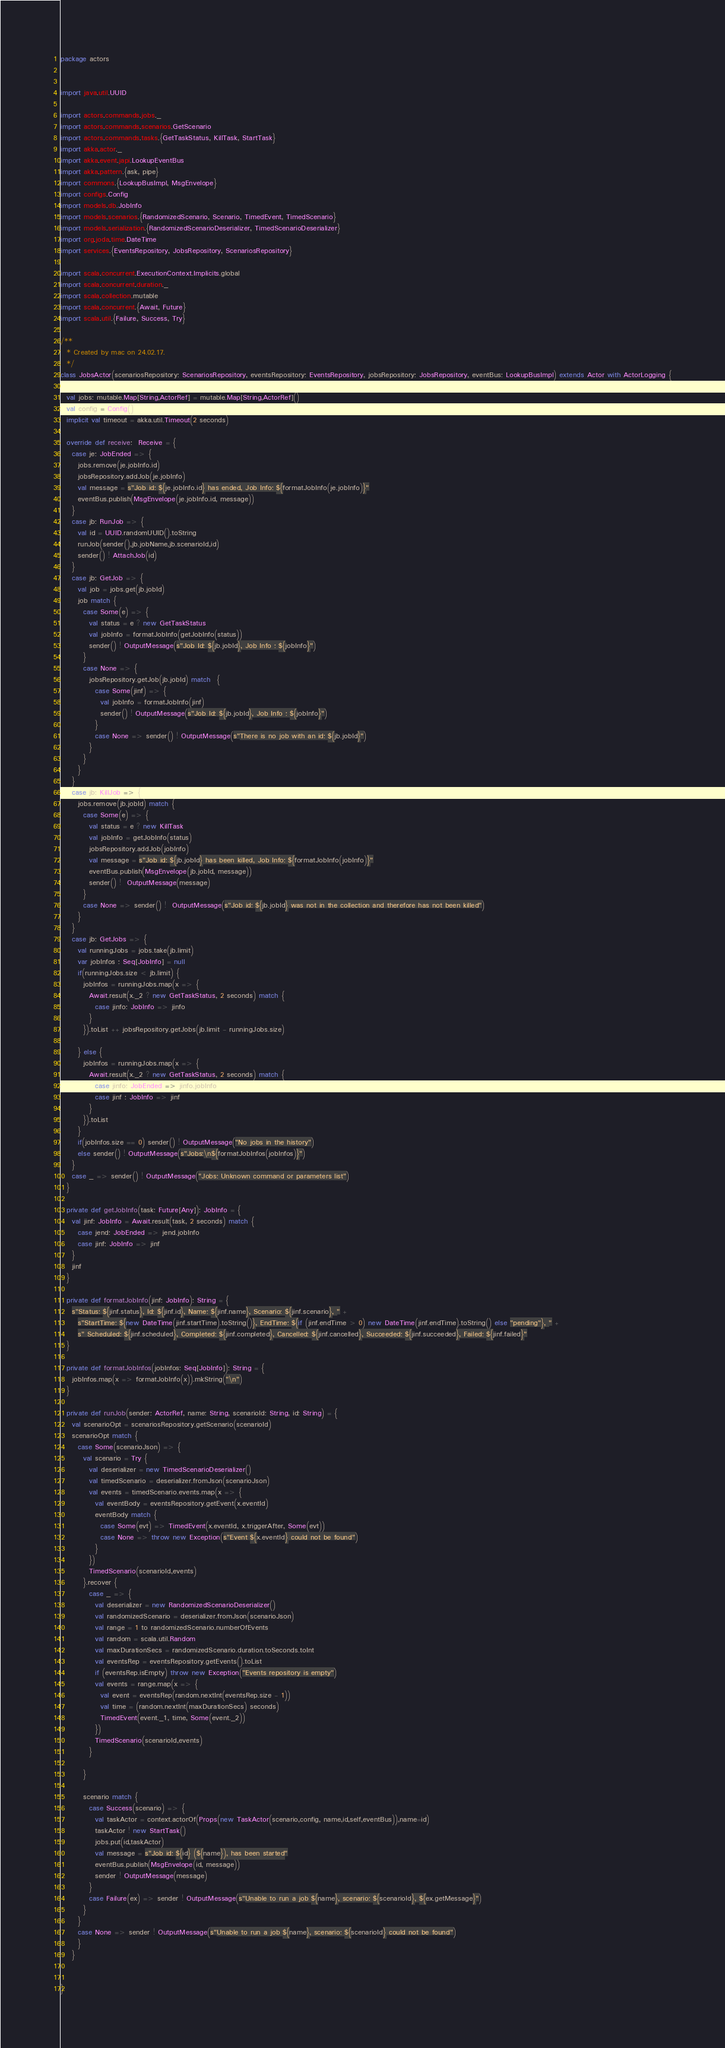<code> <loc_0><loc_0><loc_500><loc_500><_Scala_>package actors


import java.util.UUID

import actors.commands.jobs._
import actors.commands.scenarios.GetScenario
import actors.commands.tasks.{GetTaskStatus, KillTask, StartTask}
import akka.actor._
import akka.event.japi.LookupEventBus
import akka.pattern.{ask, pipe}
import commons.{LookupBusImpl, MsgEnvelope}
import configs.Config
import models.db.JobInfo
import models.scenarios.{RandomizedScenario, Scenario, TimedEvent, TimedScenario}
import models.serialization.{RandomizedScenarioDeserializer, TimedScenarioDeserializer}
import org.joda.time.DateTime
import services.{EventsRepository, JobsRepository, ScenariosRepository}

import scala.concurrent.ExecutionContext.Implicits.global
import scala.concurrent.duration._
import scala.collection.mutable
import scala.concurrent.{Await, Future}
import scala.util.{Failure, Success, Try}

/**
  * Created by mac on 24.02.17.
  */
class JobsActor(scenariosRepository: ScenariosRepository, eventsRepository: EventsRepository, jobsRepository: JobsRepository, eventBus: LookupBusImpl) extends Actor with ActorLogging {

  val jobs: mutable.Map[String,ActorRef] = mutable.Map[String,ActorRef]()
  val config = Config()
  implicit val timeout = akka.util.Timeout(2 seconds)

  override def receive:  Receive = {
    case je: JobEnded => {
      jobs.remove(je.jobInfo.id)
      jobsRepository.addJob(je.jobInfo)
      val message = s"Job id: ${je.jobInfo.id} has ended, Job Info: ${formatJobInfo(je.jobInfo)}"
      eventBus.publish(MsgEnvelope(je.jobInfo.id, message))
    }
    case jb: RunJob => {
      val id = UUID.randomUUID().toString
      runJob(sender(),jb.jobName,jb.scenarioId,id)
      sender() ! AttachJob(id)
    }
    case jb: GetJob => {
      val job = jobs.get(jb.jobId)
      job match {
        case Some(e) => {
          val status = e ? new GetTaskStatus
          val jobInfo = formatJobInfo(getJobInfo(status))
          sender() ! OutputMessage(s"Job Id: ${jb.jobId}, Job Info : ${jobInfo}")
        }
        case None => {
          jobsRepository.getJob(jb.jobId) match  {
            case Some(jinf) => {
              val jobInfo = formatJobInfo(jinf)
              sender() ! OutputMessage(s"Job Id: ${jb.jobId}, Job Info : ${jobInfo}")
            }
            case None => sender() ! OutputMessage(s"There is no job with an id: ${jb.jobId}")
          }
        }
      }
    }
    case jb: KillJob => {
      jobs.remove(jb.jobId) match {
        case Some(e) => {
          val status = e ? new KillTask
          val jobInfo = getJobInfo(status)
          jobsRepository.addJob(jobInfo)
          val message = s"Job id: ${jb.jobId} has been killed, Job Info: ${formatJobInfo(jobInfo)}"
          eventBus.publish(MsgEnvelope(jb.jobId, message))
          sender() !  OutputMessage(message)
        }
        case None => sender() !  OutputMessage(s"Job id: ${jb.jobId} was not in the collection and therefore has not been killed")
      }
    }
    case jb: GetJobs => {
      val runningJobs = jobs.take(jb.limit)
      var jobInfos : Seq[JobInfo] = null
      if(runningJobs.size < jb.limit) {
        jobInfos = runningJobs.map(x => {
          Await.result(x._2 ? new GetTaskStatus, 2 seconds) match {
            case jinfo: JobInfo => jinfo
          }
        }).toList ++ jobsRepository.getJobs(jb.limit - runningJobs.size)

      } else {
        jobInfos = runningJobs.map(x => {
          Await.result(x._2 ? new GetTaskStatus, 2 seconds) match {
            case jinfo: JobEnded => jinfo.jobInfo
            case jinf : JobInfo => jinf
          }
        }).toList
      }
      if(jobInfos.size == 0) sender() ! OutputMessage("No jobs in the history")
      else sender() ! OutputMessage(s"Jobs:\n${formatJobInfos(jobInfos)}")
    }
    case _ => sender() ! OutputMessage("Jobs: Unknown command or parameters list")
  }

  private def getJobInfo(task: Future[Any]): JobInfo = {
    val jinf: JobInfo = Await.result(task, 2 seconds) match {
      case jend: JobEnded => jend.jobInfo
      case jinf: JobInfo => jinf
    }
    jinf
  }

  private def formatJobInfo(jinf: JobInfo): String = {
    s"Status: ${jinf.status}, Id: ${jinf.id}, Name: ${jinf.name}, Scenario: ${jinf.scenario}, " +
      s"StartTime: ${new DateTime(jinf.startTime).toString()}, EndTime: ${if (jinf.endTime > 0) new DateTime(jinf.endTime).toString() else "pending"}, " +
      s" Scheduled: ${jinf.scheduled}, Completed: ${jinf.completed}, Cancelled: ${jinf.cancelled}, Succeeded: ${jinf.succeeded}, Failed: ${jinf.failed}"
  }

  private def formatJobInfos(jobInfos: Seq[JobInfo]): String = {
    jobInfos.map(x => formatJobInfo(x)).mkString("\n")
  }

  private def runJob(sender: ActorRef, name: String, scenarioId: String, id: String) = {
    val scenarioOpt = scenariosRepository.getScenario(scenarioId)
    scenarioOpt match {
      case Some(scenarioJson) => {
        val scenario = Try {
          val deserializer = new TimedScenarioDeserializer()
          val timedScenario = deserializer.fromJson(scenarioJson)
          val events = timedScenario.events.map(x => {
            val eventBody = eventsRepository.getEvent(x.eventId)
            eventBody match {
              case Some(evt) => TimedEvent(x.eventId, x.triggerAfter, Some(evt))
              case None => throw new Exception(s"Event ${x.eventId} could not be found")
            }
          })
          TimedScenario(scenarioId,events)
        }.recover {
          case _ => {
            val deserializer = new RandomizedScenarioDeserializer()
            val randomizedScenario = deserializer.fromJson(scenarioJson)
            val range = 1 to randomizedScenario.numberOfEvents
            val random = scala.util.Random
            val maxDurationSecs = randomizedScenario.duration.toSeconds.toInt
            val eventsRep = eventsRepository.getEvents().toList
            if (eventsRep.isEmpty) throw new Exception("Events repository is empty")
            val events = range.map(x => {
              val event = eventsRep(random.nextInt(eventsRep.size - 1))
              val time = (random.nextInt(maxDurationSecs) seconds)
              TimedEvent(event._1, time, Some(event._2))
            })
            TimedScenario(scenarioId,events)
          }

        }

        scenario match {
          case Success(scenario) => {
            val taskActor = context.actorOf(Props(new TaskActor(scenario,config, name,id,self,eventBus)),name=id)
            taskActor ! new StartTask()
            jobs.put(id,taskActor)
            val message = s"Job id: ${id} (${name}), has been started"
            eventBus.publish(MsgEnvelope(id, message))
            sender ! OutputMessage(message)
          }
          case Failure(ex) => sender ! OutputMessage(s"Unable to run a job ${name}, scenario: ${scenarioId}, ${ex.getMessage}")
        }
      }
      case None => sender ! OutputMessage(s"Unable to run a job ${name}, scenario: ${scenarioId} could not be found")
      }
    }


}
</code> 